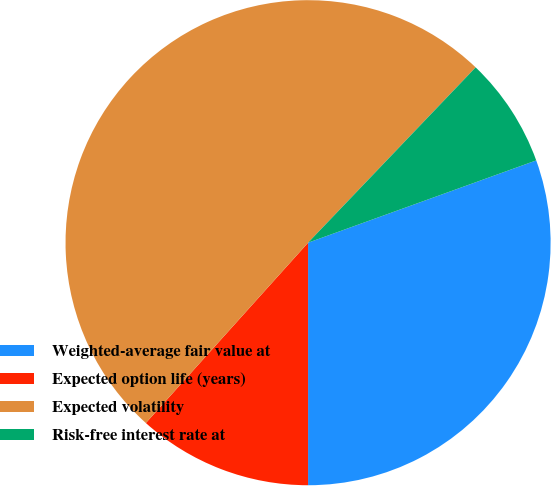Convert chart to OTSL. <chart><loc_0><loc_0><loc_500><loc_500><pie_chart><fcel>Weighted-average fair value at<fcel>Expected option life (years)<fcel>Expected volatility<fcel>Risk-free interest rate at<nl><fcel>30.51%<fcel>11.66%<fcel>50.48%<fcel>7.35%<nl></chart> 